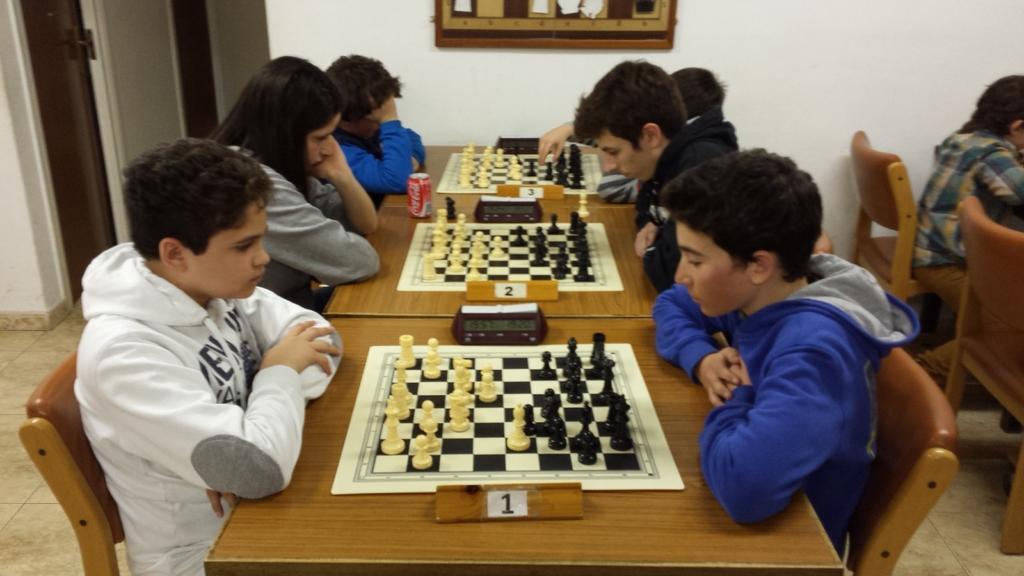Describe this image in one or two sentences. This image seems like a chess competition is being taken place. In the middle of the image there are tables and chess boards, naming one, two, three and alarm clocks set on each table. On one of the table there is a coke bottle. On the left of the image there is a boy with white hoodie and right of the image there is a boy with blue hoodie. The wall in the background is having a frame. On the left background there is a door. There are many chairs for the players to sit in the room. 